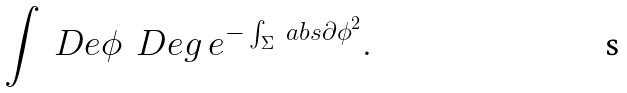<formula> <loc_0><loc_0><loc_500><loc_500>\int \ D e \phi \ \ D e g \ e ^ { - \int _ { \Sigma } \ a b s { \partial \phi } ^ { 2 } } .</formula> 